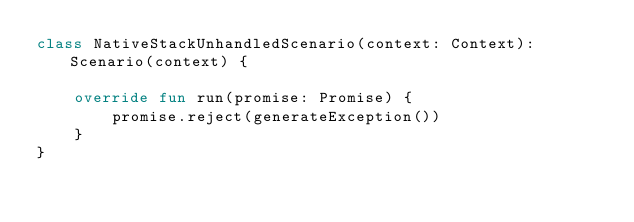<code> <loc_0><loc_0><loc_500><loc_500><_Kotlin_>class NativeStackUnhandledScenario(context: Context): Scenario(context) {

    override fun run(promise: Promise) {
        promise.reject(generateException())
    }
}
</code> 